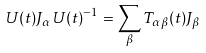Convert formula to latex. <formula><loc_0><loc_0><loc_500><loc_500>U ( t ) J _ { \alpha } U ( t ) ^ { - 1 } = \sum _ { \beta } T _ { \alpha \beta } ( t ) J _ { \beta }</formula> 